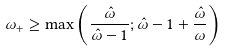Convert formula to latex. <formula><loc_0><loc_0><loc_500><loc_500>\omega _ { + } \geq \max \left ( \frac { \hat { \omega } } { \hat { \omega } - 1 } ; \hat { \omega } - 1 + \frac { \hat { \omega } } { \omega } \right )</formula> 